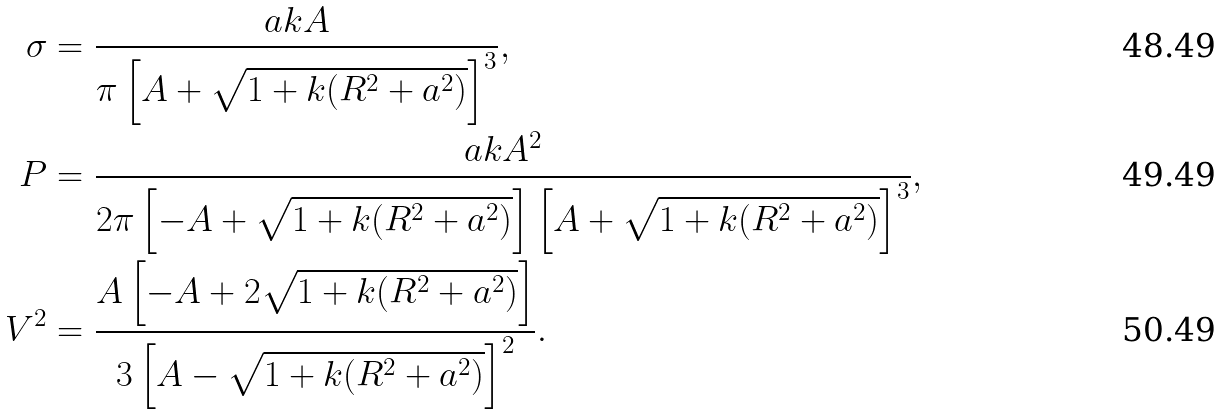Convert formula to latex. <formula><loc_0><loc_0><loc_500><loc_500>\sigma & = \frac { a k A } { \pi \left [ A + \sqrt { 1 + k ( R ^ { 2 } + a ^ { 2 } ) } \right ] ^ { 3 } } , \\ P & = \frac { a k A ^ { 2 } } { 2 \pi \left [ - A + \sqrt { 1 + k ( R ^ { 2 } + a ^ { 2 } ) } \right ] \left [ A + \sqrt { 1 + k ( R ^ { 2 } + a ^ { 2 } ) } \right ] ^ { 3 } } , \\ V ^ { 2 } & = \frac { A \left [ - A + 2 \sqrt { 1 + k ( R ^ { 2 } + a ^ { 2 } ) } \right ] } { 3 \left [ A - \sqrt { 1 + k ( R ^ { 2 } + a ^ { 2 } ) } \right ] ^ { 2 } } .</formula> 